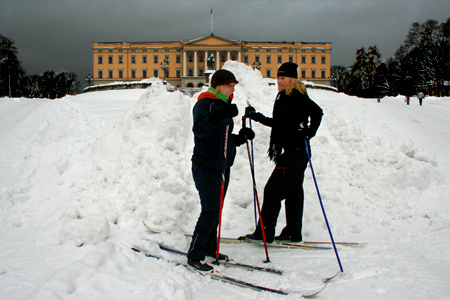Who is wearing trousers? The girl is wearing trousers. 